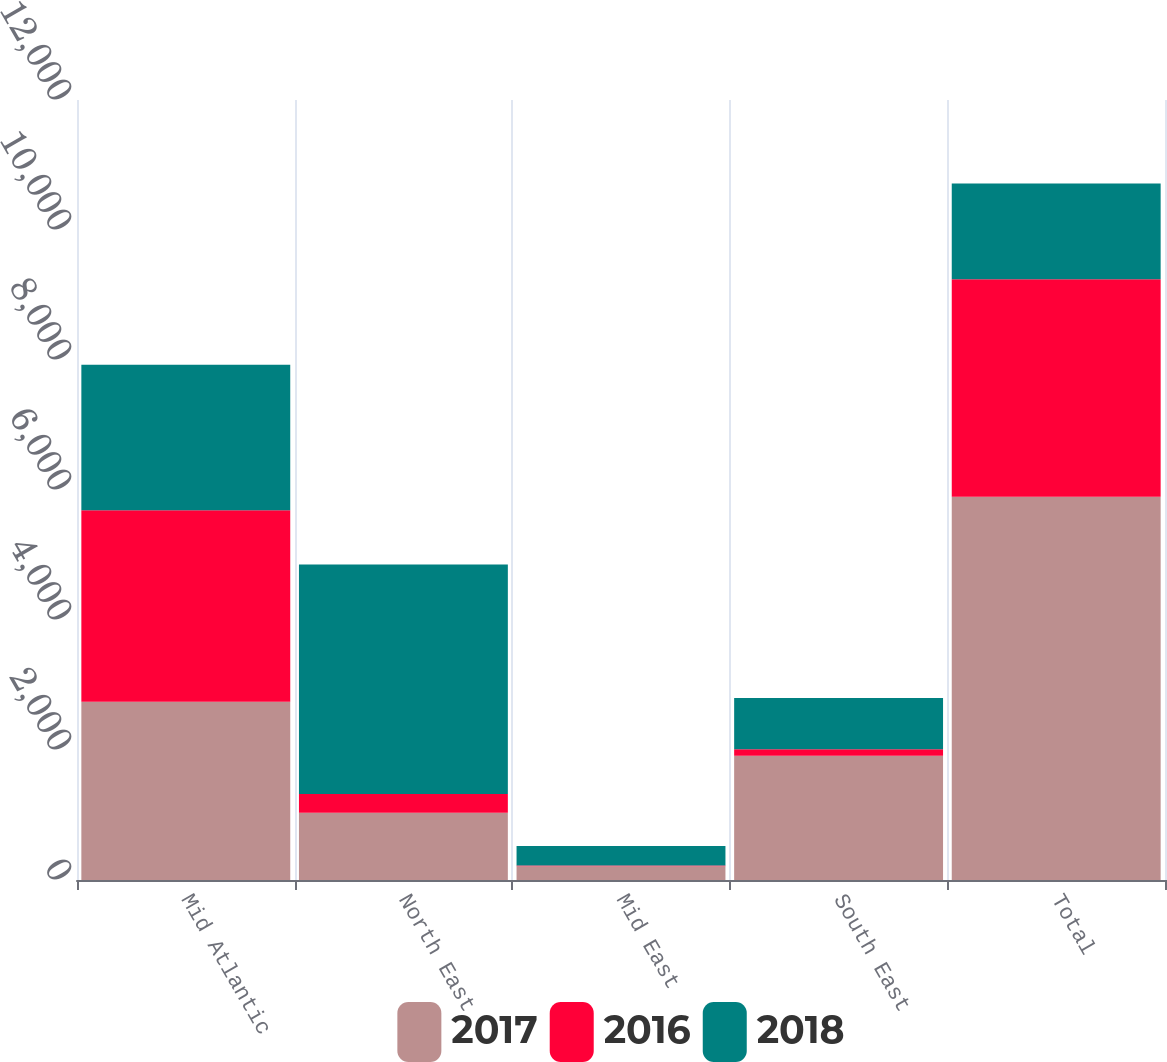<chart> <loc_0><loc_0><loc_500><loc_500><stacked_bar_chart><ecel><fcel>Mid Atlantic<fcel>North East<fcel>Mid East<fcel>South East<fcel>Total<nl><fcel>2017<fcel>2743<fcel>1033<fcel>211<fcel>1911<fcel>5898<nl><fcel>2016<fcel>2945<fcel>290<fcel>11<fcel>99<fcel>3345<nl><fcel>2018<fcel>2240<fcel>3530<fcel>303<fcel>791<fcel>1472<nl></chart> 